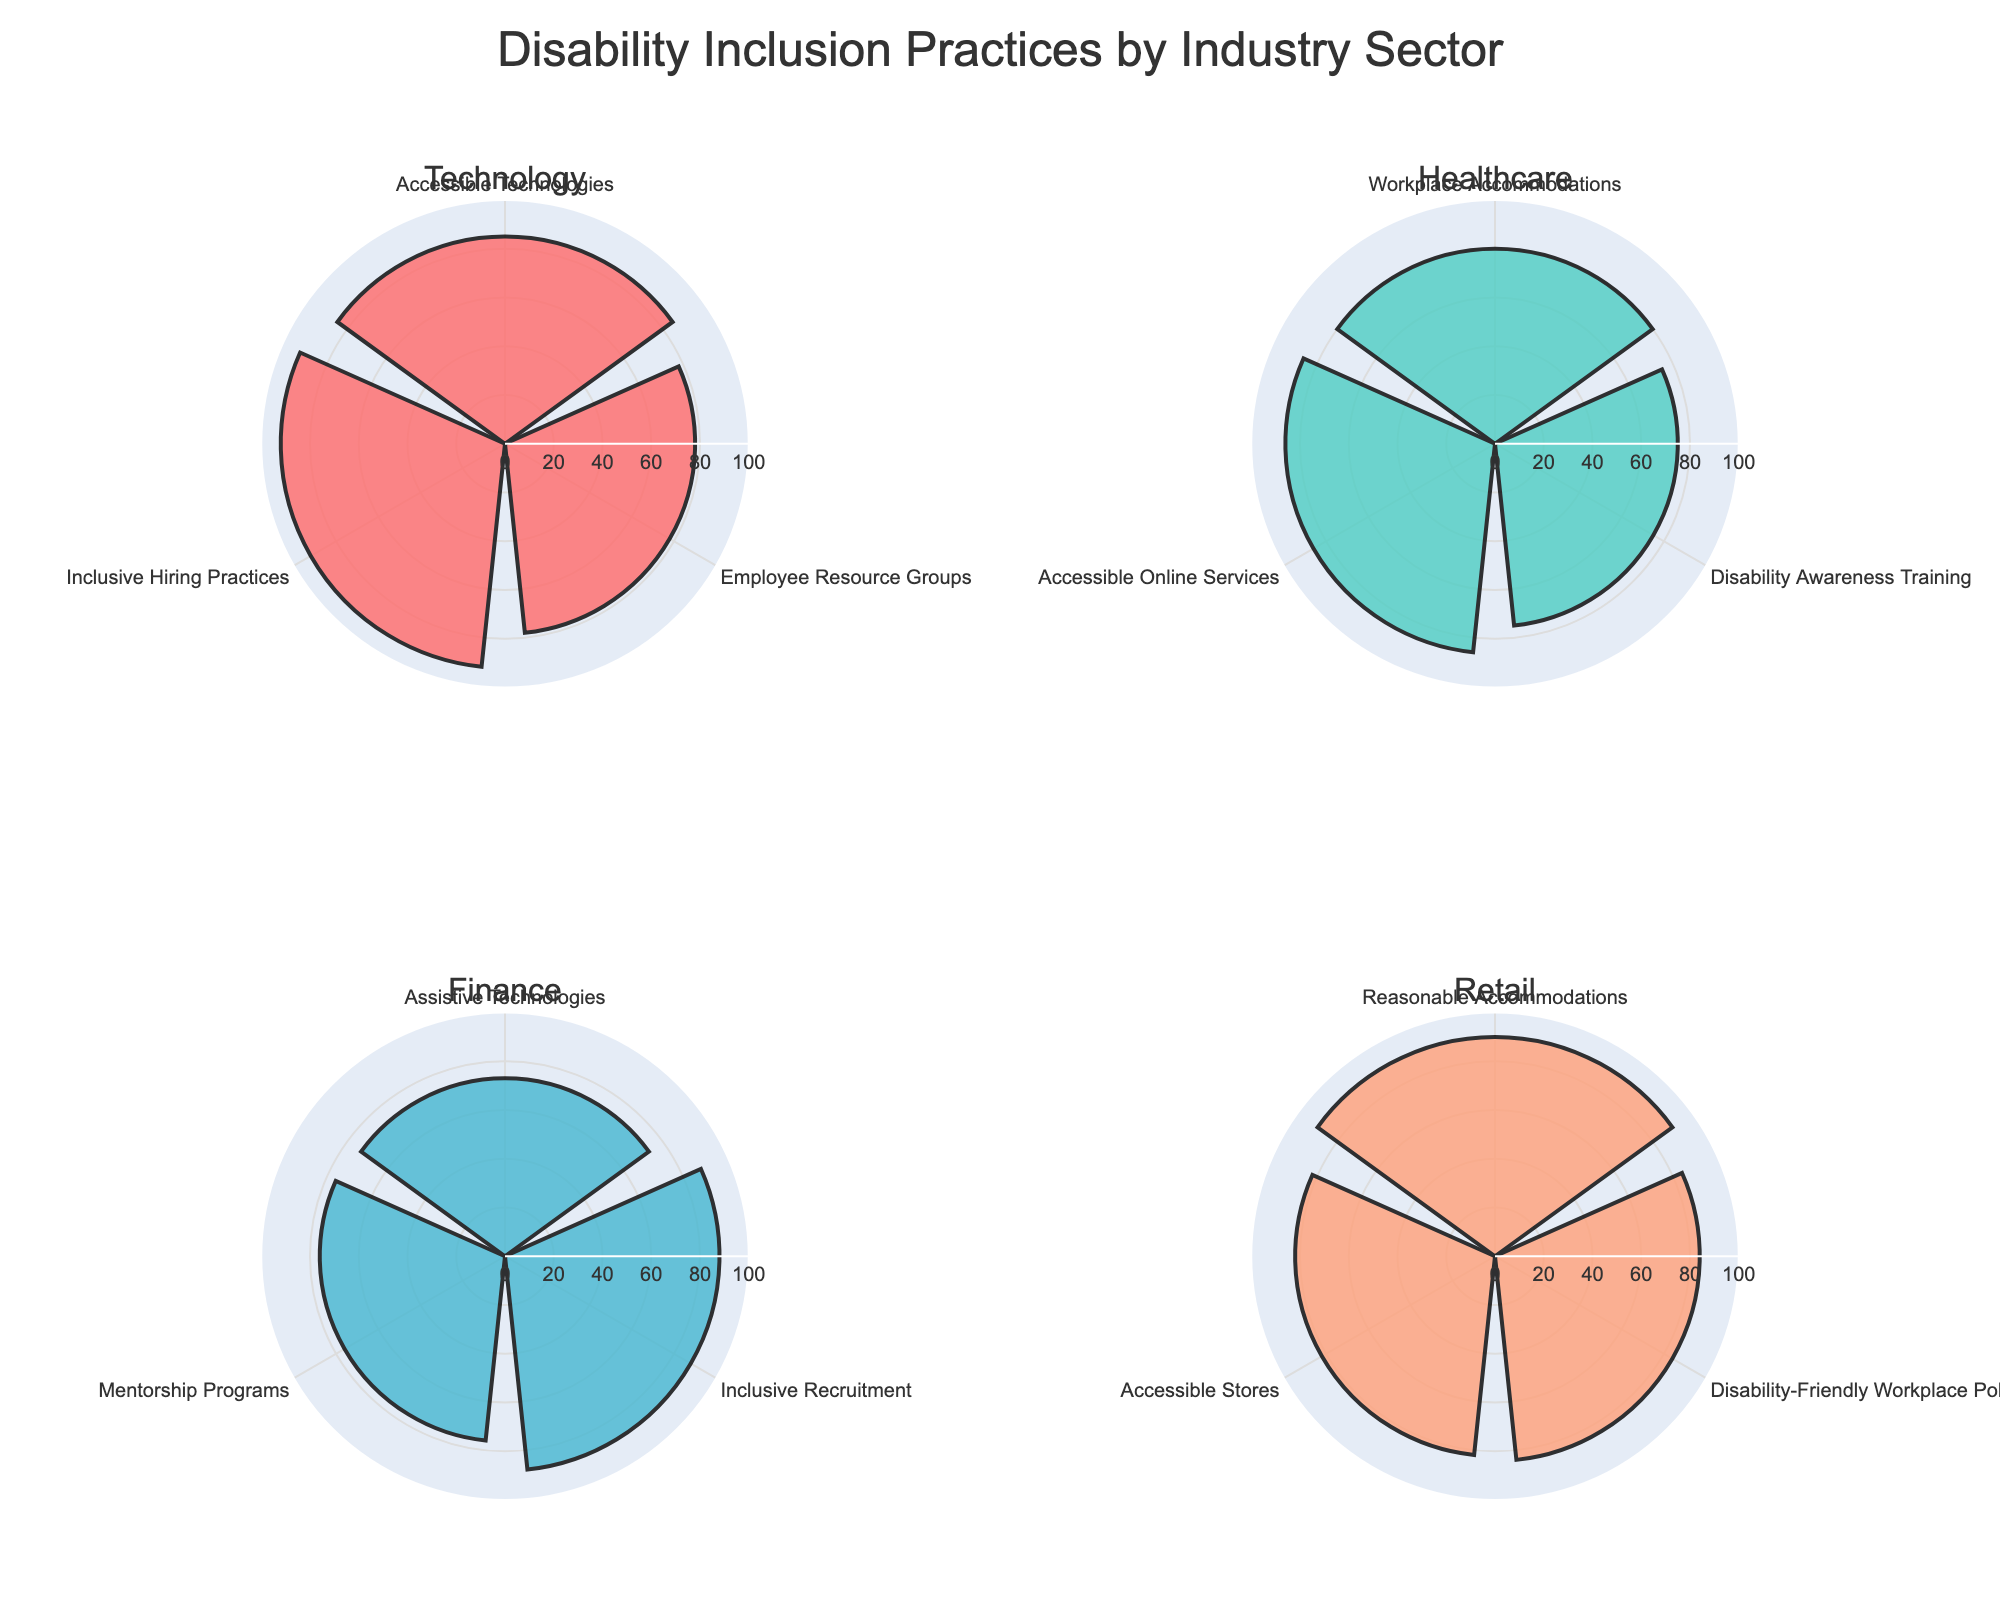what are the four industry sectors shown in the figure? The four industry sectors are listed as subplot titles: Technology, Healthcare, Finance, and Retail
Answer: Technology, Healthcare, Finance, and Retail Which industry sector has the highest value for any inclusion practice? By comparing all the highest values in each subplot, the highest value is in the Technology sector for Inclusive Hiring Practices with a value of 92
Answer: Technology What is the average value of inclusion practices in the Retail sector? The values for the Retail sector are 90, 84, and 82. Adding them up gives 256, and dividing by 3 results in an average of about 85.3
Answer: 85.3 Which two inclusion practices have the closest values in the Technology sector? In the Technology sector, the values are 85, 78, and 92. The closest values are for Accessible Technologies (85) and Employee Resource Groups (78) with a difference of 7
Answer: Accessible Technologies and Employee Resource Groups How many inclusion practices have a value above 80 in the Healthcare sector? In the Healthcare sector, the values are 80, 75, and 86. Two of these values are above 80: Workplace Accommodations (80) and Accessible Online Services (86)
Answer: 2 Which inclusion practice in the Finance sector has the highest value? By examining the values in the Finance sector, the highest value is for Inclusive Recruitment at 88
Answer: Inclusive Recruitment What is the difference between the highest and lowest values in the Retail sector? The values in the Retail sector are 90, 84, and 82. The highest value is 90 and the lowest value is 82. The difference is 90 - 82 = 8
Answer: 8 What is the median value of inclusion practices in the Technology sector? The values in the Technology sector are 85, 78, and 92. Arranging them in order: 78, 85, 92. The median value is the middle one, which is 85
Answer: 85 Between Technology and Healthcare sectors, which has a higher average value for inclusion practices? The Technology sector has values 85, 78, and 92, averaging (85+78+92)/3 = 85. The Healthcare sector has values 80, 75, and 86, averaging (80+75+86)/3 = 80.33. Thus, Technology has a higher average value
Answer: Technology What is the highest value for Accessible Technologies among all sectors included in the figure? Accessible Technologies is present only in the Technology sector with a value of 85. None of the other sectors have this inclusion practice
Answer: 85 